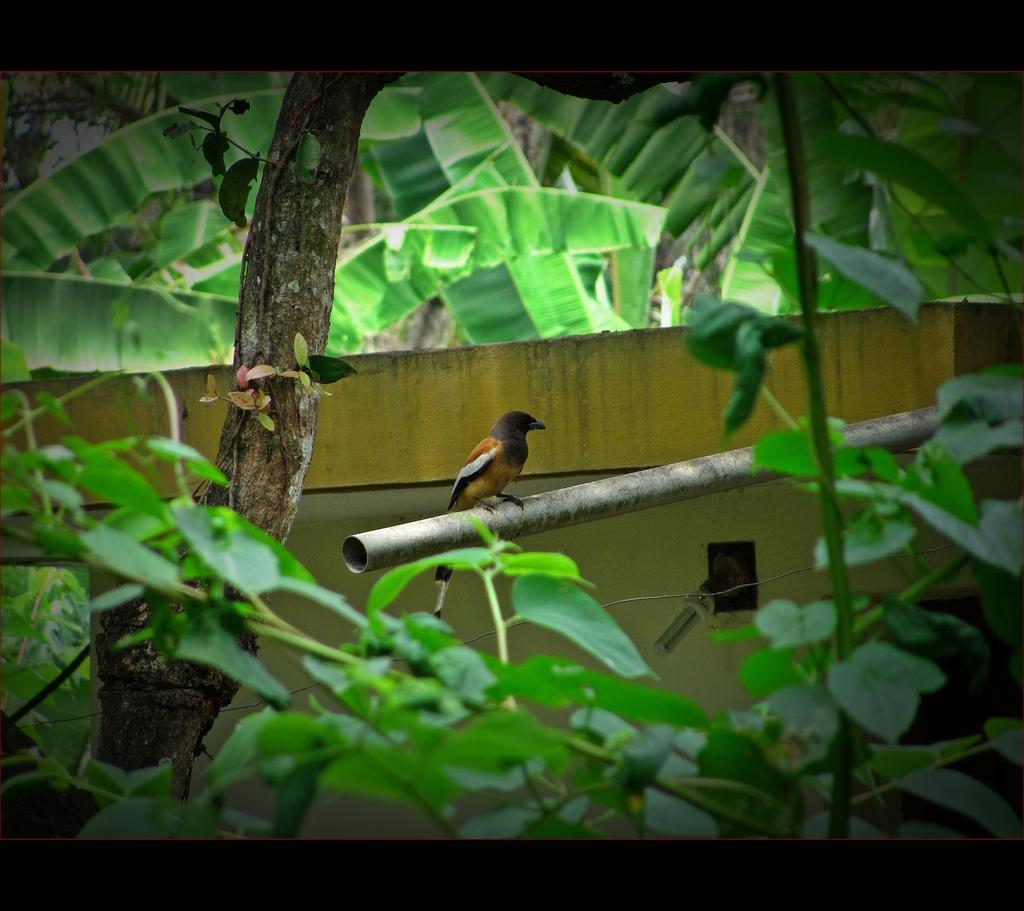What is on the pole in the image? There is a bird on a pole in the image. What type of vegetation can be seen in the image? There are plants and trees visible in the image. Where is the dog being held in the image? There is no dog present in the image. 